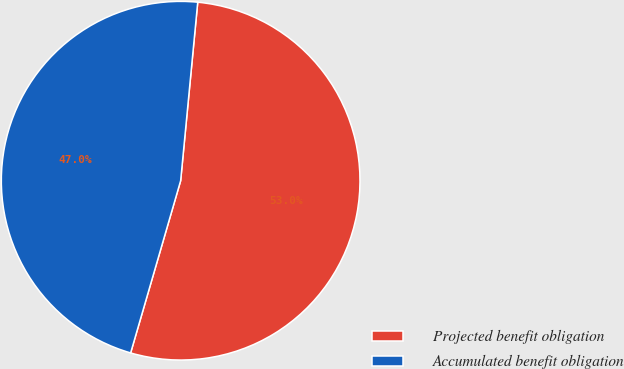Convert chart. <chart><loc_0><loc_0><loc_500><loc_500><pie_chart><fcel>Projected benefit obligation<fcel>Accumulated benefit obligation<nl><fcel>52.98%<fcel>47.02%<nl></chart> 